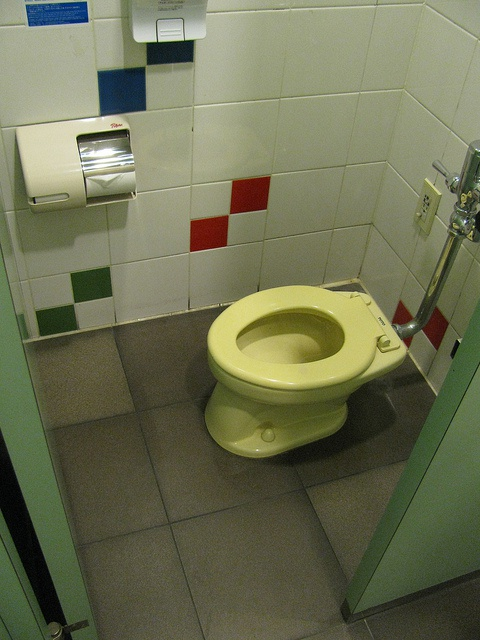Describe the objects in this image and their specific colors. I can see a toilet in darkgray, olive, khaki, and black tones in this image. 